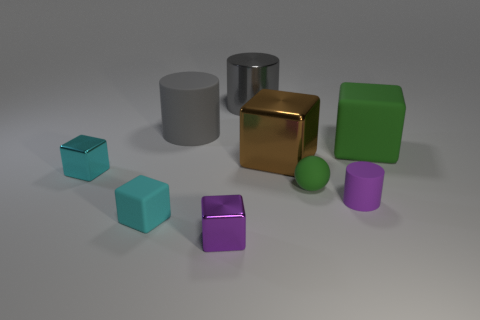Can you describe the shapes and their arrangement in the image? The image showcases a variety of geometric shapes laid out on a flat surface. I see a cube, cylinder, sphere, and what may be prisms or blocks, each boasting different colors and arranged with enough space to distinguish them individually. They seem carefully placed to give a sense of orderly variety. 